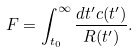Convert formula to latex. <formula><loc_0><loc_0><loc_500><loc_500>F = \int ^ { \infty } _ { t _ { 0 } } \frac { d t ^ { \prime } c ( t ^ { \prime } ) } { R ( t ^ { \prime } ) } .</formula> 